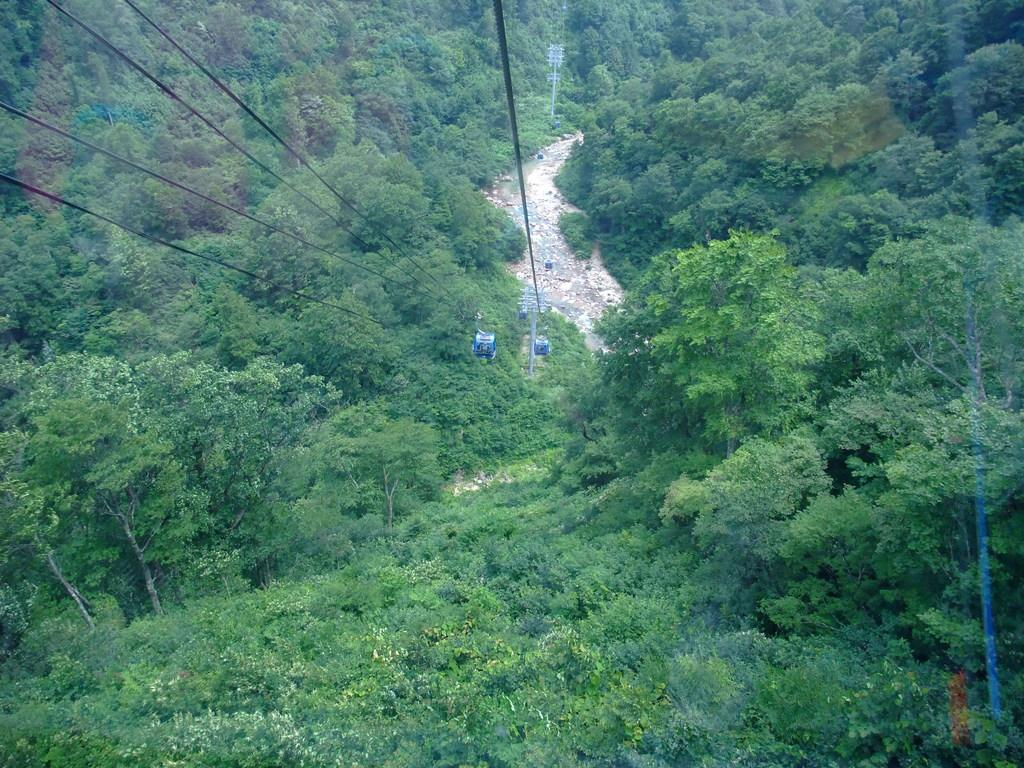What type of transportation is shown in the image? There are cable cars in the image. How are the cable cars suspended? The cable cars are on ropes. What natural elements can be seen in the background of the image? There are trees visible behind the cable cars. What body of water is present in the image? There is a lake with rocks in the image. What type of recess can be seen in the image? There is no recess present in the image. What type of land is visible in the image? The image does not specifically focus on the type of land; it shows cable cars, trees, and a lake with rocks. 